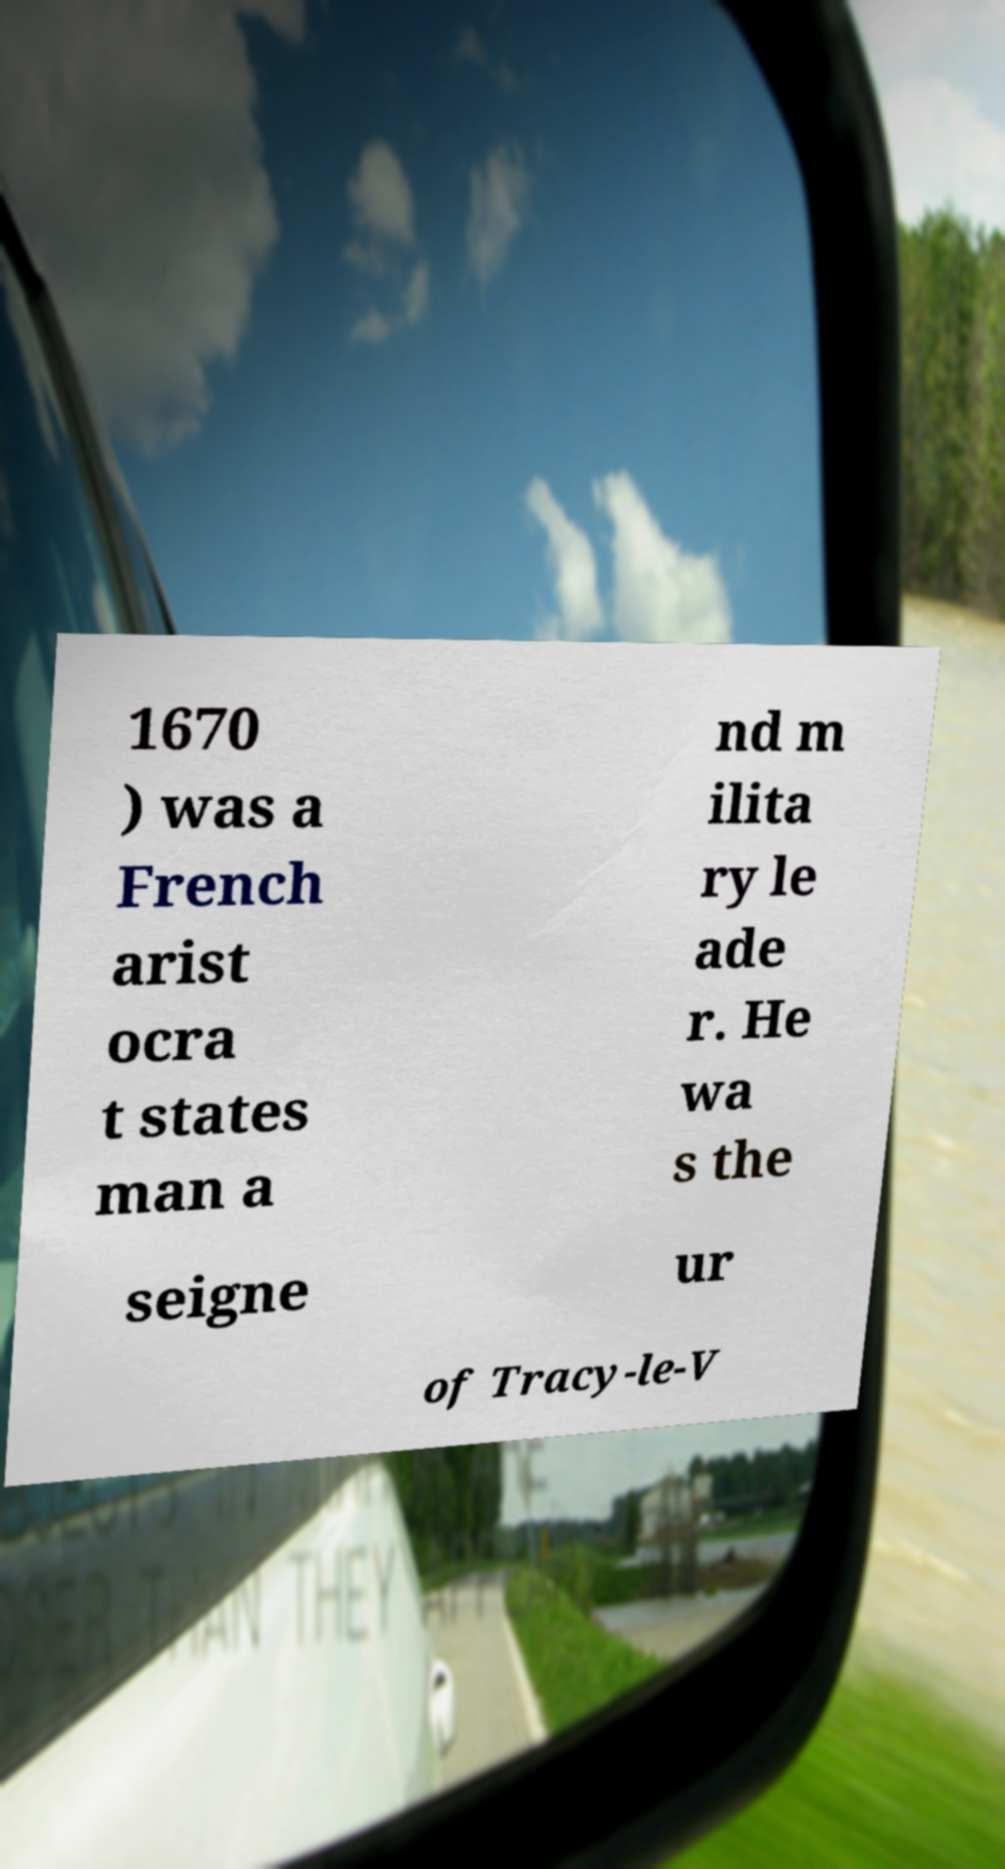Can you read and provide the text displayed in the image?This photo seems to have some interesting text. Can you extract and type it out for me? 1670 ) was a French arist ocra t states man a nd m ilita ry le ade r. He wa s the seigne ur of Tracy-le-V 